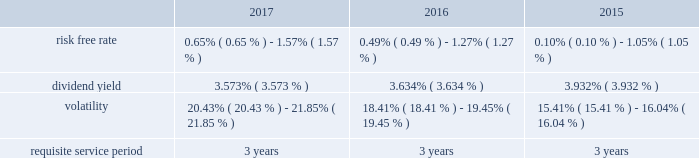Performance based restricted stock awards is generally recognized using the accelerated amortization method with each vesting tranche valued as a separate award , with a separate vesting date , consistent with the estimated value of the award at each period end .
Additionally , compensation expense is adjusted for actual forfeitures for all awards in the period that the award was forfeited .
Compensation expense for stock options is generally recognized on a straight-line basis over the requisite service period .
Maa presents stock compensation expense in the consolidated statements of operations in "general and administrative expenses" .
Effective january 1 , 2017 , the company adopted asu 2016-09 , improvements to employee share- based payment accounting , which allows employers to make a policy election to account for forfeitures as they occur .
The company elected this option using the modified retrospective transition method , with a cumulative effect adjustment to retained earnings , and there was no material effect on the consolidated financial position or results of operations taken as a whole resulting from the reversal of previously estimated forfeitures .
Total compensation expense under the stock plan was approximately $ 10.8 million , $ 12.2 million and $ 6.9 million for the years ended december 31 , 2017 , 2016 and 2015 , respectively .
Of these amounts , total compensation expense capitalized was approximately $ 0.2 million , $ 0.7 million and $ 0.7 million for the years ended december 31 , 2017 , 2016 and 2015 , respectively .
As of december 31 , 2017 , the total unrecognized compensation expense was approximately $ 14.1 million .
This cost is expected to be recognized over the remaining weighted average period of 1.2 years .
Total cash paid for the settlement of plan shares totaled $ 4.8 million , $ 2.0 million and $ 1.0 million for the years ended december 31 , 2017 , 2016 and 2015 , respectively .
Information concerning grants under the stock plan is listed below .
Restricted stock in general , restricted stock is earned based on either a service condition , performance condition , or market condition , or a combination thereof , and generally vests ratably over a period from 1 year to 5 years .
Service based awards are earned when the employee remains employed over the requisite service period and are valued on the grant date based upon the market price of maa common stock on the date of grant .
Market based awards are earned when maa reaches a specified stock price or specified return on the stock price ( price appreciation plus dividends ) and are valued on the grant date using a monte carlo simulation .
Performance based awards are earned when maa reaches certain operational goals such as funds from operations , or ffo , targets and are valued based upon the market price of maa common stock on the date of grant as well as the probability of reaching the stated targets .
Maa remeasures the fair value of the performance based awards each balance sheet date with adjustments made on a cumulative basis until the award is settled and the final compensation is known .
The weighted average grant date fair value per share of restricted stock awards granted during the years ended december 31 , 2017 , 2016 and 2015 , was $ 84.53 , $ 73.20 and $ 68.35 , respectively .
The following is a summary of the key assumptions used in the valuation calculations for market based awards granted during the years ended december 31 , 2017 , 2016 and 2015: .
The risk free rate was based on a zero coupon risk-free rate .
The minimum risk free rate was based on a period of 0.25 years for the years ended december 31 , 2017 , 2016 and 2015 .
The maximum risk free rate was based on a period of 3 years for the years ended december 31 , 2017 , 2016 and 2015 .
The dividend yield was based on the closing stock price of maa stock on the date of grant .
Volatility for maa was obtained by using a blend of both historical and implied volatility calculations .
Historical volatility was based on the standard deviation of daily total continuous returns , and implied volatility was based on the trailing month average of daily implied volatilities interpolating between the volatilities implied by stock call option contracts that were closest to the terms shown and closest to the money .
The minimum volatility was based on a period of 3 years , 2 years and 1 year for the years ended december 31 , 2017 , 2016 and 2015 , respectively .
The maximum volatility was based on a period of 1 year , 1 year and 2 years for the years ended december 31 , 2017 , 2016 and 2015 , respectively .
The requisite service period is based on the criteria for the separate programs according to the vesting schedule. .
Considering the years 2015 and 2016 , what is the percentual increase observed in the total compensation expense under the stock plan? 
Rationale: it is the compensation expense under the stock plan in 2016 divided by the 2015's , then turned into a percentage to represent the increase .
Computations: ((12.2 / 6.9) - 1)
Answer: 0.76812. 